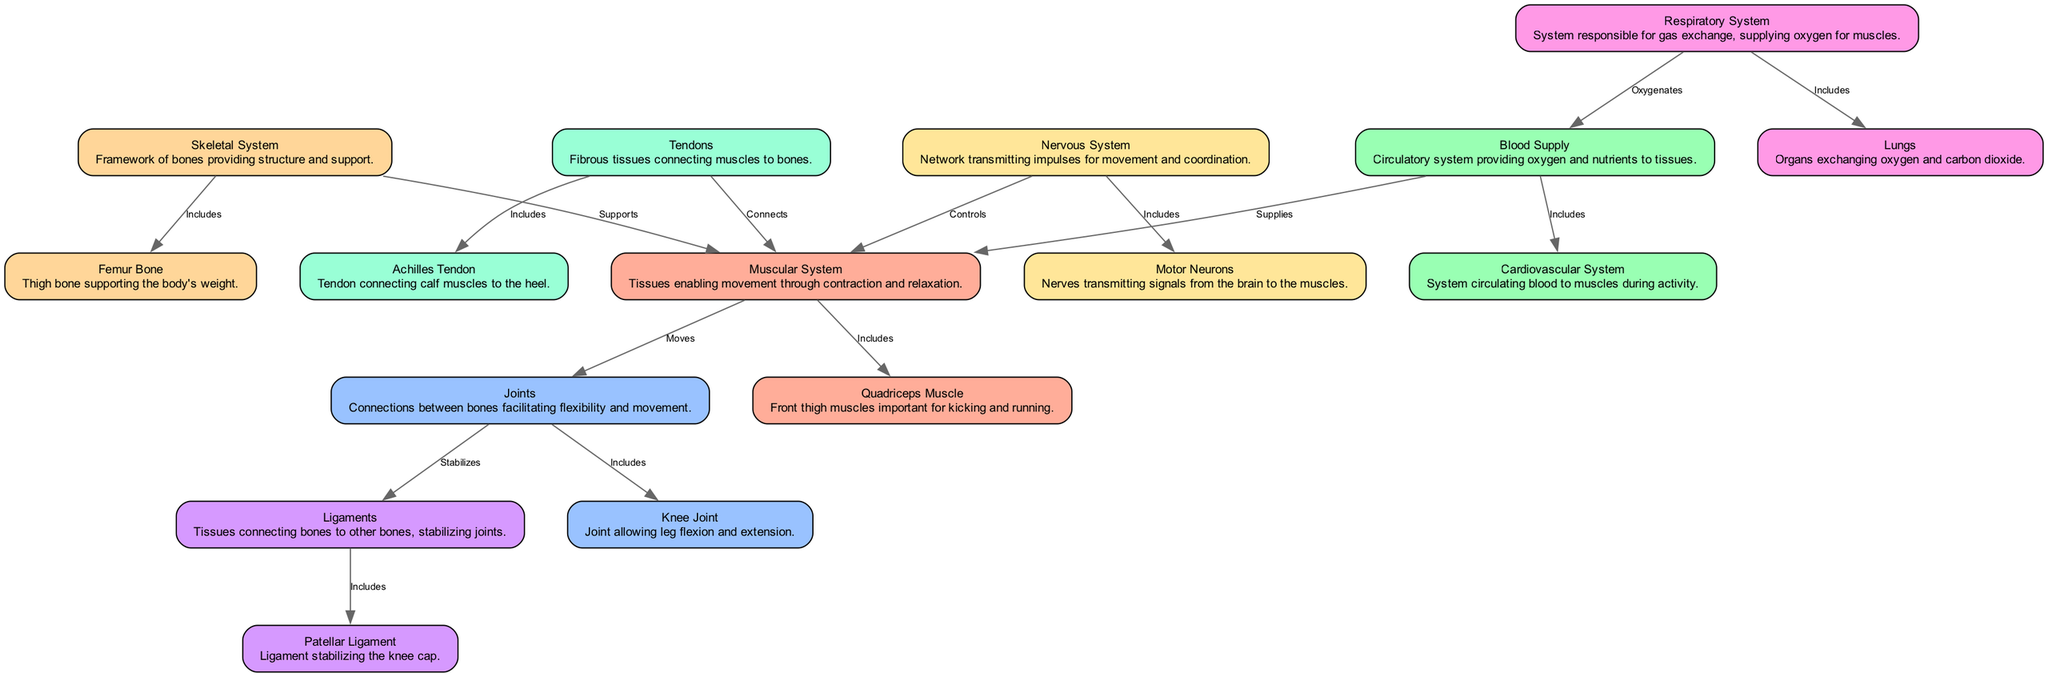What is the main role of the Skeletal System? The Skeletal System is described in the diagram as providing "structure and support." This indicates that its primary function is to form a framework that supports the body.
Answer: Structure and support Which muscle is crucial for kicking and running? The Quadriceps Muscle is mentioned in the diagram as the "front thigh muscles important for kicking and running." This directly identifies the specific role of this muscle during activities like Gaelic football.
Answer: Quadriceps Muscle How many nodes are in the diagram? By counting all the unique nodes listed in the provided data, we find there are 16 nodes representing different components of the musculoskeletal system.
Answer: 16 What connects muscles to bones? The diagram states that Tendons are the fibrous tissues that "connect muscles to bones." This piece of information directly answers the question of what serves this specific function.
Answer: Tendons Which system is responsible for gas exchange? The diagram describes the Respiratory System as the system responsible for "gas exchange," which provides necessary oxygen to the muscles during activities like running and kicking in Gaelic football.
Answer: Respiratory System What stabilizes the knee joint? The Patellar Ligament is indicated as the ligament that "stabilizes the knee cap." This means this ligament plays a vital role in maintaining the stability of the knee joint during physical activities.
Answer: Patellar Ligament How does the Nervous System influence muscle action? The Nervous System is noted for "transmitting impulses for movement and coordination," meaning it controls muscle contractions by sending signals from the brain to the muscles. This describes how the system governs muscle activity.
Answer: Transmits impulses What supports the Muscular System? The diagram indicates that the Skeletal System "supports" the Muscular System, showing that the bones provide the necessary structure for muscle attachment and function.
Answer: Skeletal System What supplies oxygen to the muscles? According to the diagram, the Blood Supply is responsible for providing "oxygen and nutrients to tissues," which directly links it to the overall performance of muscles during activity.
Answer: Blood Supply 